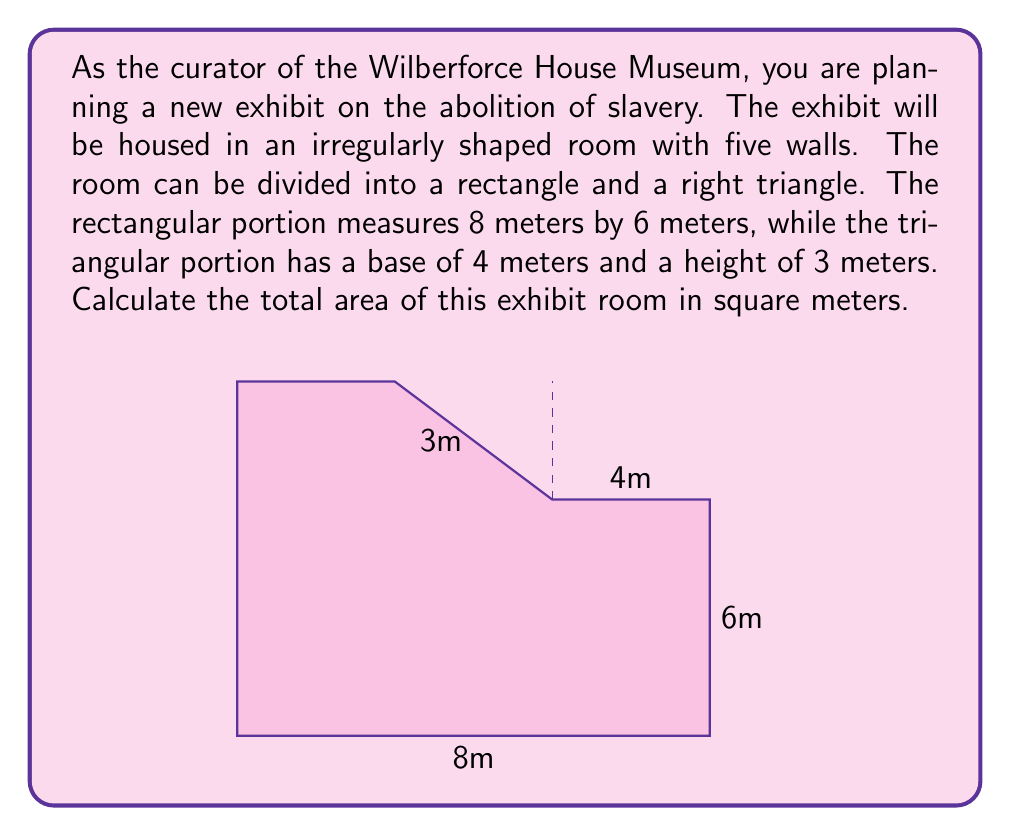Provide a solution to this math problem. To solve this problem, we need to calculate the areas of the rectangular and triangular portions separately, then add them together.

1. Area of the rectangular portion:
   $$ A_{rectangle} = length \times width $$
   $$ A_{rectangle} = 8 \text{ m} \times 6 \text{ m} = 48 \text{ m}^2 $$

2. Area of the triangular portion:
   The formula for the area of a triangle is:
   $$ A_{triangle} = \frac{1}{2} \times base \times height $$
   $$ A_{triangle} = \frac{1}{2} \times 4 \text{ m} \times 3 \text{ m} = 6 \text{ m}^2 $$

3. Total area of the exhibit room:
   $$ A_{total} = A_{rectangle} + A_{triangle} $$
   $$ A_{total} = 48 \text{ m}^2 + 6 \text{ m}^2 = 54 \text{ m}^2 $$

Therefore, the total area of the irregularly shaped exhibit room is 54 square meters.
Answer: $54 \text{ m}^2$ 